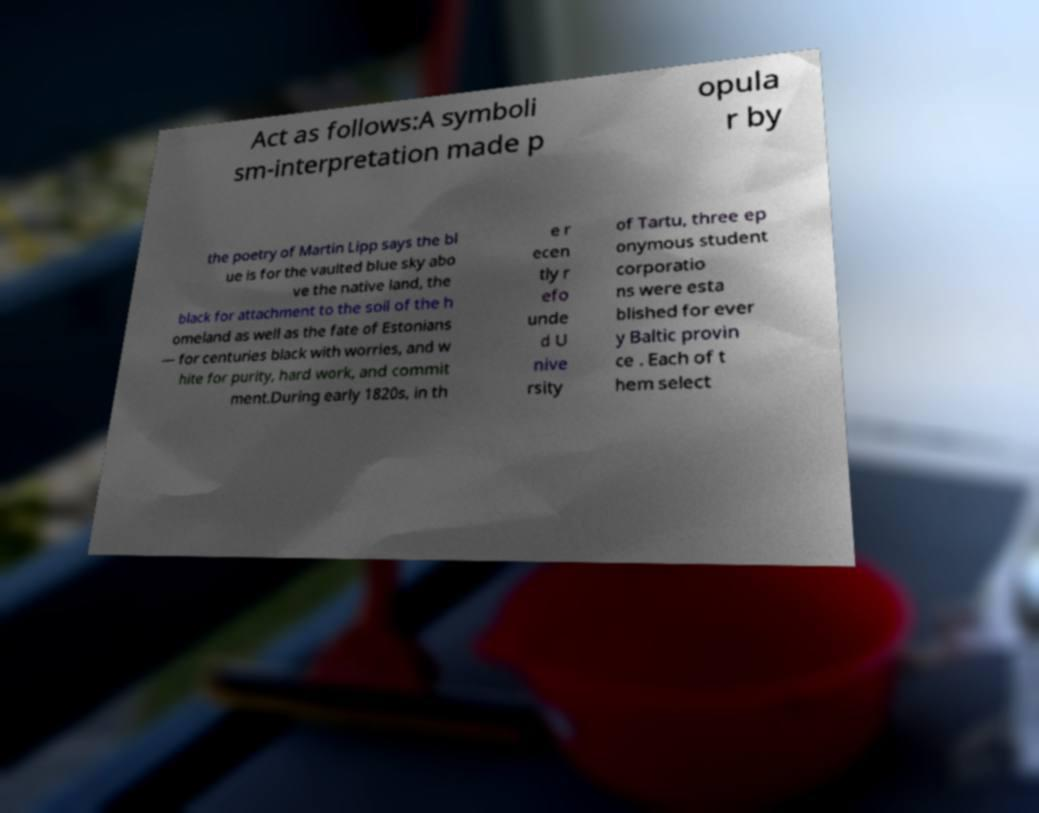Could you assist in decoding the text presented in this image and type it out clearly? Act as follows:A symboli sm-interpretation made p opula r by the poetry of Martin Lipp says the bl ue is for the vaulted blue sky abo ve the native land, the black for attachment to the soil of the h omeland as well as the fate of Estonians — for centuries black with worries, and w hite for purity, hard work, and commit ment.During early 1820s, in th e r ecen tly r efo unde d U nive rsity of Tartu, three ep onymous student corporatio ns were esta blished for ever y Baltic provin ce . Each of t hem select 